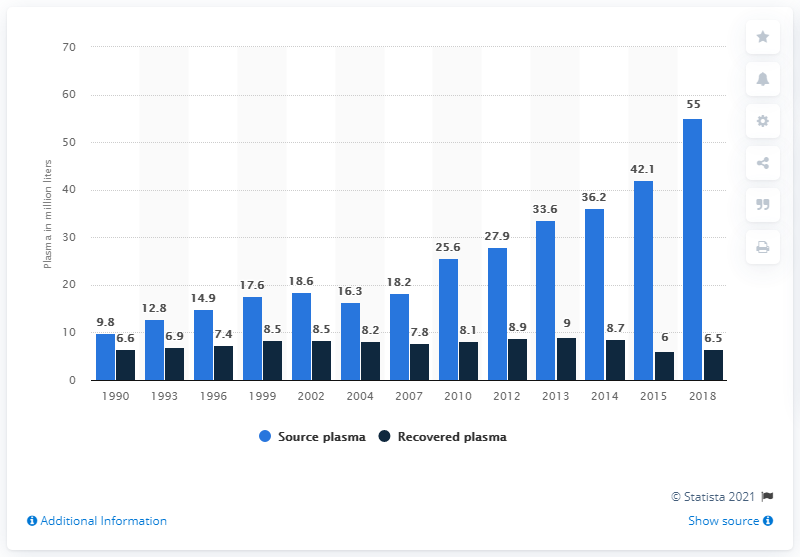Highlight a few significant elements in this photo. In 2018, the global volume of recovered plasma was 6.5... In 2018, the global volume of source plasma was approximately 55,000 units. 